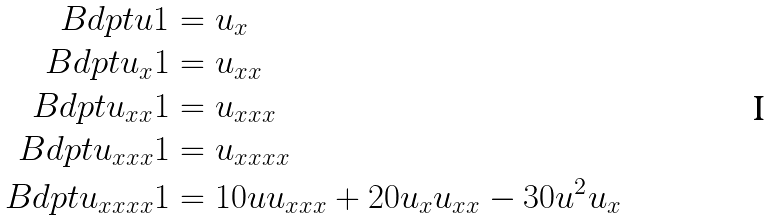<formula> <loc_0><loc_0><loc_500><loc_500>\ B d p t { u } { 1 } & = u _ { x } \\ \ B d p t { u _ { x } } { 1 } & = u _ { x x } \\ \ B d p t { u _ { x x } } { 1 } & = u _ { x x x } \\ \ B d p t { u _ { x x x } } { 1 } & = u _ { x x x x } \\ \ B d p t { u _ { x x x x } } { 1 } & = 1 0 u u _ { x x x } + 2 0 u _ { x } u _ { x x } - 3 0 u ^ { 2 } u _ { x }</formula> 